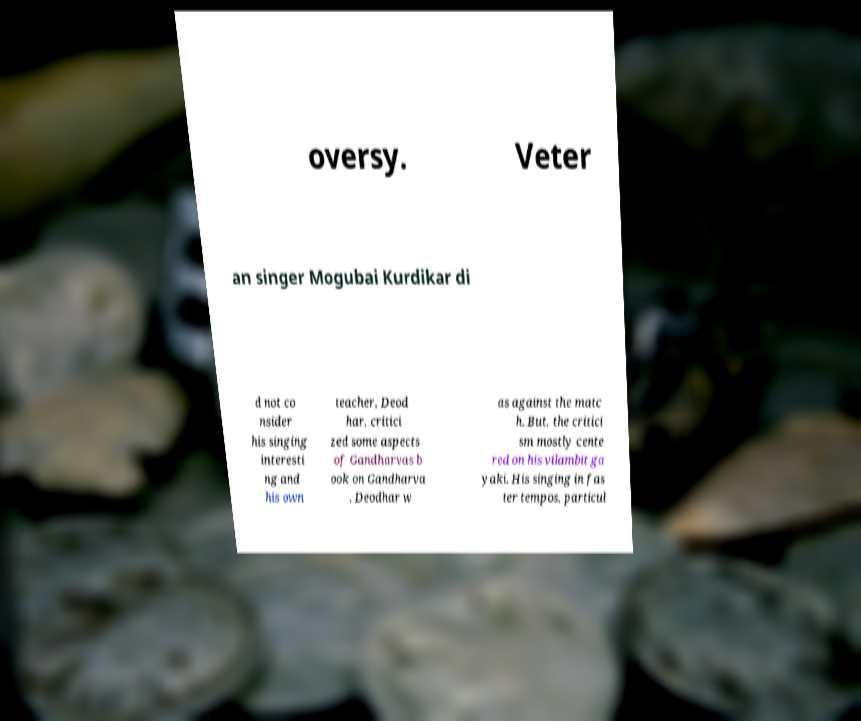Could you extract and type out the text from this image? oversy. Veter an singer Mogubai Kurdikar di d not co nsider his singing interesti ng and his own teacher, Deod har, critici zed some aspects of Gandharvas b ook on Gandharva , Deodhar w as against the matc h. But, the critici sm mostly cente red on his vilambit ga yaki. His singing in fas ter tempos, particul 